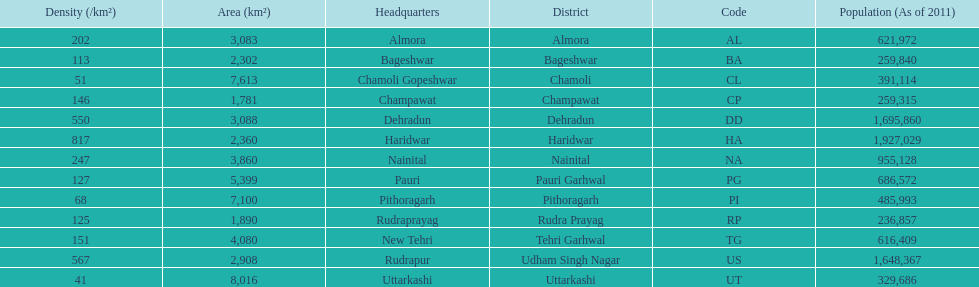Tell me the number of districts with an area over 5000. 4. 